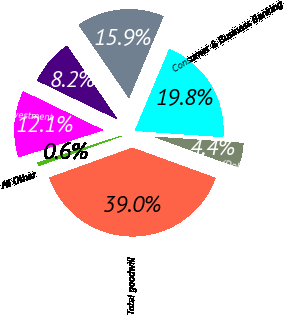<chart> <loc_0><loc_0><loc_500><loc_500><pie_chart><fcel>(Dollars in millions)<fcel>Consumer & Business Banking<fcel>Global Banking<fcel>Global Markets<fcel>Global Wealth & Investment<fcel>All Other<fcel>Total goodwill<nl><fcel>4.42%<fcel>19.77%<fcel>15.93%<fcel>8.25%<fcel>12.09%<fcel>0.58%<fcel>38.96%<nl></chart> 